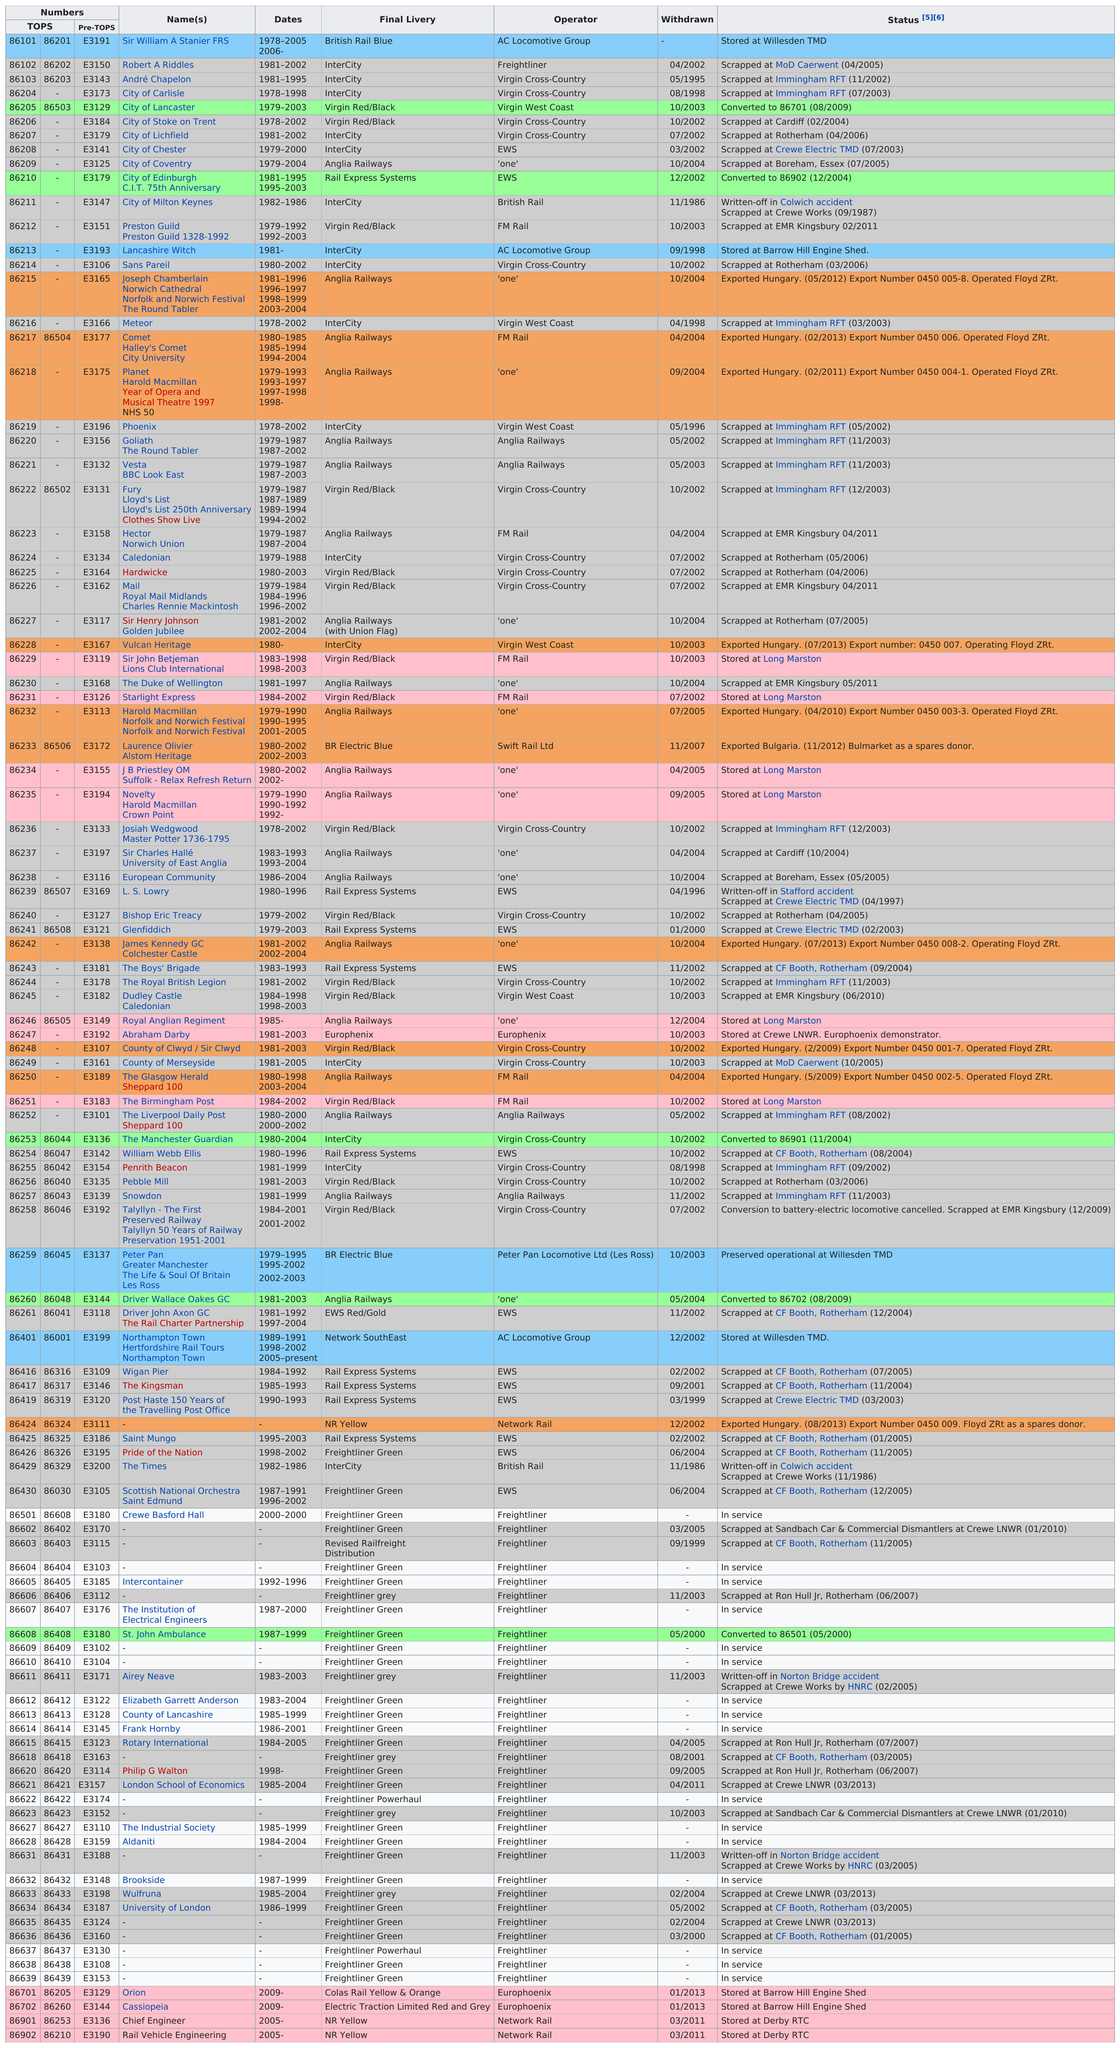Specify some key components in this picture. There are currently 16 aircraft that are still in service. In the year 2002, a total of 30 withdrawals took place. EWS operated 13 locomotives. Currently, there are 16 trains that are still operational. Five vehicles were written off due to accidents. 